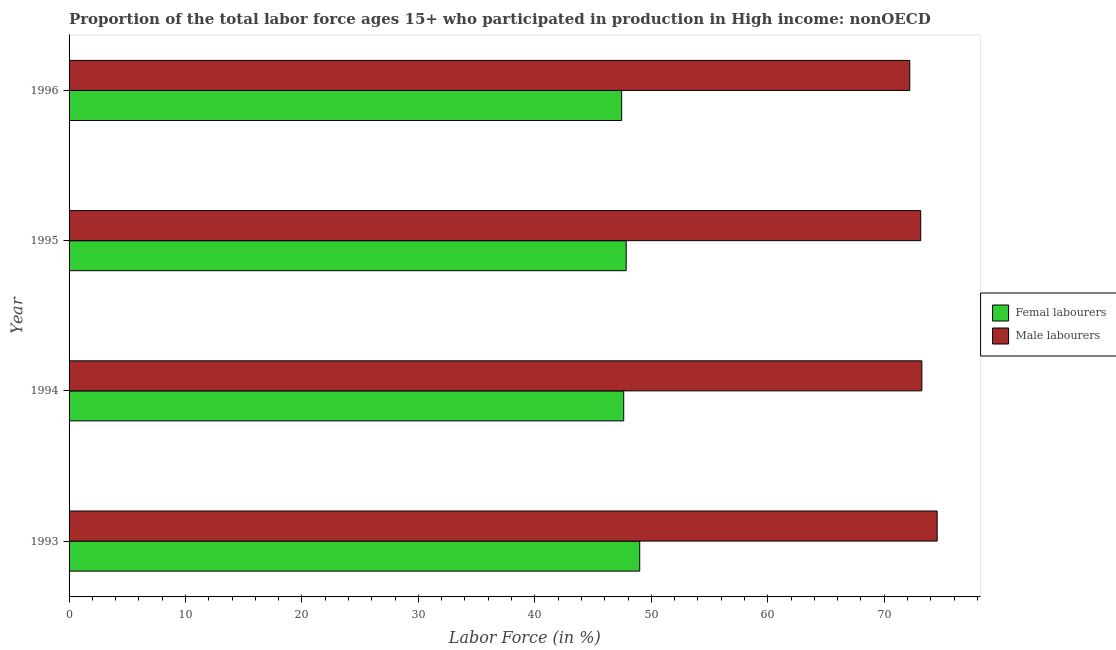How many different coloured bars are there?
Ensure brevity in your answer.  2. Are the number of bars on each tick of the Y-axis equal?
Keep it short and to the point. Yes. How many bars are there on the 2nd tick from the top?
Your answer should be very brief. 2. What is the label of the 4th group of bars from the top?
Your response must be concise. 1993. What is the percentage of male labour force in 1996?
Give a very brief answer. 72.2. Across all years, what is the maximum percentage of female labor force?
Keep it short and to the point. 49.01. Across all years, what is the minimum percentage of male labour force?
Provide a succinct answer. 72.2. In which year was the percentage of male labour force minimum?
Give a very brief answer. 1996. What is the total percentage of male labour force in the graph?
Your answer should be compact. 293.12. What is the difference between the percentage of female labor force in 1993 and that in 1996?
Your response must be concise. 1.55. What is the difference between the percentage of female labor force in 1994 and the percentage of male labour force in 1993?
Offer a terse response. -26.92. What is the average percentage of male labour force per year?
Give a very brief answer. 73.28. In the year 1996, what is the difference between the percentage of male labour force and percentage of female labor force?
Provide a succinct answer. 24.74. In how many years, is the percentage of female labor force greater than 48 %?
Provide a short and direct response. 1. Is the difference between the percentage of female labor force in 1994 and 1995 greater than the difference between the percentage of male labour force in 1994 and 1995?
Ensure brevity in your answer.  No. What is the difference between the highest and the second highest percentage of male labour force?
Offer a terse response. 1.31. What is the difference between the highest and the lowest percentage of male labour force?
Provide a succinct answer. 2.35. In how many years, is the percentage of male labour force greater than the average percentage of male labour force taken over all years?
Offer a terse response. 1. What does the 2nd bar from the top in 1993 represents?
Provide a succinct answer. Femal labourers. What does the 1st bar from the bottom in 1995 represents?
Provide a succinct answer. Femal labourers. Are all the bars in the graph horizontal?
Keep it short and to the point. Yes. How many years are there in the graph?
Give a very brief answer. 4. How are the legend labels stacked?
Your answer should be very brief. Vertical. What is the title of the graph?
Give a very brief answer. Proportion of the total labor force ages 15+ who participated in production in High income: nonOECD. Does "Agricultural land" appear as one of the legend labels in the graph?
Keep it short and to the point. No. What is the label or title of the X-axis?
Your answer should be compact. Labor Force (in %). What is the Labor Force (in %) in Femal labourers in 1993?
Your answer should be very brief. 49.01. What is the Labor Force (in %) of Male labourers in 1993?
Your response must be concise. 74.55. What is the Labor Force (in %) of Femal labourers in 1994?
Offer a terse response. 47.63. What is the Labor Force (in %) in Male labourers in 1994?
Offer a terse response. 73.24. What is the Labor Force (in %) in Femal labourers in 1995?
Give a very brief answer. 47.84. What is the Labor Force (in %) in Male labourers in 1995?
Offer a very short reply. 73.14. What is the Labor Force (in %) in Femal labourers in 1996?
Offer a very short reply. 47.46. What is the Labor Force (in %) of Male labourers in 1996?
Keep it short and to the point. 72.2. Across all years, what is the maximum Labor Force (in %) of Femal labourers?
Provide a short and direct response. 49.01. Across all years, what is the maximum Labor Force (in %) in Male labourers?
Give a very brief answer. 74.55. Across all years, what is the minimum Labor Force (in %) of Femal labourers?
Offer a very short reply. 47.46. Across all years, what is the minimum Labor Force (in %) in Male labourers?
Make the answer very short. 72.2. What is the total Labor Force (in %) of Femal labourers in the graph?
Make the answer very short. 191.94. What is the total Labor Force (in %) of Male labourers in the graph?
Give a very brief answer. 293.12. What is the difference between the Labor Force (in %) in Femal labourers in 1993 and that in 1994?
Give a very brief answer. 1.37. What is the difference between the Labor Force (in %) in Male labourers in 1993 and that in 1994?
Give a very brief answer. 1.31. What is the difference between the Labor Force (in %) of Femal labourers in 1993 and that in 1995?
Your answer should be compact. 1.16. What is the difference between the Labor Force (in %) of Male labourers in 1993 and that in 1995?
Offer a terse response. 1.41. What is the difference between the Labor Force (in %) of Femal labourers in 1993 and that in 1996?
Offer a terse response. 1.55. What is the difference between the Labor Force (in %) in Male labourers in 1993 and that in 1996?
Ensure brevity in your answer.  2.35. What is the difference between the Labor Force (in %) of Femal labourers in 1994 and that in 1995?
Keep it short and to the point. -0.21. What is the difference between the Labor Force (in %) of Male labourers in 1994 and that in 1995?
Your response must be concise. 0.1. What is the difference between the Labor Force (in %) in Femal labourers in 1994 and that in 1996?
Ensure brevity in your answer.  0.18. What is the difference between the Labor Force (in %) in Male labourers in 1994 and that in 1996?
Offer a very short reply. 1.04. What is the difference between the Labor Force (in %) of Femal labourers in 1995 and that in 1996?
Your response must be concise. 0.39. What is the difference between the Labor Force (in %) in Male labourers in 1995 and that in 1996?
Ensure brevity in your answer.  0.94. What is the difference between the Labor Force (in %) of Femal labourers in 1993 and the Labor Force (in %) of Male labourers in 1994?
Your answer should be very brief. -24.23. What is the difference between the Labor Force (in %) in Femal labourers in 1993 and the Labor Force (in %) in Male labourers in 1995?
Your answer should be very brief. -24.13. What is the difference between the Labor Force (in %) in Femal labourers in 1993 and the Labor Force (in %) in Male labourers in 1996?
Ensure brevity in your answer.  -23.19. What is the difference between the Labor Force (in %) of Femal labourers in 1994 and the Labor Force (in %) of Male labourers in 1995?
Your response must be concise. -25.51. What is the difference between the Labor Force (in %) in Femal labourers in 1994 and the Labor Force (in %) in Male labourers in 1996?
Your response must be concise. -24.56. What is the difference between the Labor Force (in %) of Femal labourers in 1995 and the Labor Force (in %) of Male labourers in 1996?
Provide a succinct answer. -24.35. What is the average Labor Force (in %) of Femal labourers per year?
Ensure brevity in your answer.  47.98. What is the average Labor Force (in %) in Male labourers per year?
Give a very brief answer. 73.28. In the year 1993, what is the difference between the Labor Force (in %) in Femal labourers and Labor Force (in %) in Male labourers?
Offer a terse response. -25.54. In the year 1994, what is the difference between the Labor Force (in %) in Femal labourers and Labor Force (in %) in Male labourers?
Your answer should be very brief. -25.6. In the year 1995, what is the difference between the Labor Force (in %) in Femal labourers and Labor Force (in %) in Male labourers?
Provide a succinct answer. -25.29. In the year 1996, what is the difference between the Labor Force (in %) in Femal labourers and Labor Force (in %) in Male labourers?
Your answer should be very brief. -24.74. What is the ratio of the Labor Force (in %) in Femal labourers in 1993 to that in 1994?
Make the answer very short. 1.03. What is the ratio of the Labor Force (in %) in Male labourers in 1993 to that in 1994?
Your answer should be compact. 1.02. What is the ratio of the Labor Force (in %) in Femal labourers in 1993 to that in 1995?
Your response must be concise. 1.02. What is the ratio of the Labor Force (in %) in Male labourers in 1993 to that in 1995?
Offer a terse response. 1.02. What is the ratio of the Labor Force (in %) of Femal labourers in 1993 to that in 1996?
Offer a very short reply. 1.03. What is the ratio of the Labor Force (in %) of Male labourers in 1993 to that in 1996?
Make the answer very short. 1.03. What is the ratio of the Labor Force (in %) in Male labourers in 1994 to that in 1995?
Your answer should be very brief. 1. What is the ratio of the Labor Force (in %) in Femal labourers in 1994 to that in 1996?
Make the answer very short. 1. What is the ratio of the Labor Force (in %) of Male labourers in 1994 to that in 1996?
Your answer should be compact. 1.01. What is the ratio of the Labor Force (in %) of Femal labourers in 1995 to that in 1996?
Your answer should be very brief. 1.01. What is the difference between the highest and the second highest Labor Force (in %) of Femal labourers?
Keep it short and to the point. 1.16. What is the difference between the highest and the second highest Labor Force (in %) of Male labourers?
Offer a terse response. 1.31. What is the difference between the highest and the lowest Labor Force (in %) of Femal labourers?
Give a very brief answer. 1.55. What is the difference between the highest and the lowest Labor Force (in %) of Male labourers?
Offer a terse response. 2.35. 